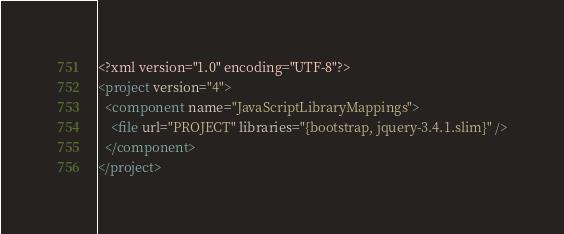Convert code to text. <code><loc_0><loc_0><loc_500><loc_500><_XML_><?xml version="1.0" encoding="UTF-8"?>
<project version="4">
  <component name="JavaScriptLibraryMappings">
    <file url="PROJECT" libraries="{bootstrap, jquery-3.4.1.slim}" />
  </component>
</project></code> 